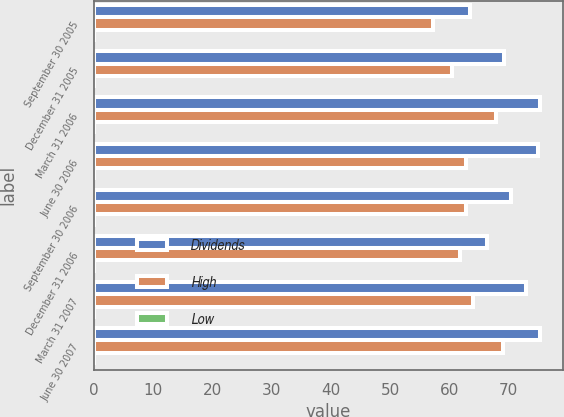Convert chart to OTSL. <chart><loc_0><loc_0><loc_500><loc_500><stacked_bar_chart><ecel><fcel>September 30 2005<fcel>December 31 2005<fcel>March 31 2006<fcel>June 30 2006<fcel>September 30 2006<fcel>December 31 2006<fcel>March 31 2007<fcel>June 30 2007<nl><fcel>Dividends<fcel>63.44<fcel>69.24<fcel>75.34<fcel>74.91<fcel>70.42<fcel>66.38<fcel>72.95<fcel>75.28<nl><fcel>High<fcel>57.28<fcel>60.49<fcel>67.91<fcel>62.83<fcel>62.8<fcel>61.83<fcel>63.93<fcel>69.07<nl><fcel>Low<fcel>0.06<fcel>0.06<fcel>0.06<fcel>0.09<fcel>0.09<fcel>0.09<fcel>0.09<fcel>0.12<nl></chart> 